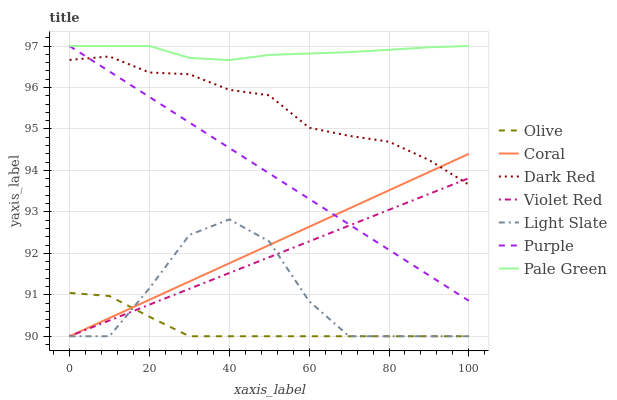Does Olive have the minimum area under the curve?
Answer yes or no. Yes. Does Pale Green have the maximum area under the curve?
Answer yes or no. Yes. Does Purple have the minimum area under the curve?
Answer yes or no. No. Does Purple have the maximum area under the curve?
Answer yes or no. No. Is Violet Red the smoothest?
Answer yes or no. Yes. Is Light Slate the roughest?
Answer yes or no. Yes. Is Purple the smoothest?
Answer yes or no. No. Is Purple the roughest?
Answer yes or no. No. Does Violet Red have the lowest value?
Answer yes or no. Yes. Does Purple have the lowest value?
Answer yes or no. No. Does Pale Green have the highest value?
Answer yes or no. Yes. Does Dark Red have the highest value?
Answer yes or no. No. Is Olive less than Pale Green?
Answer yes or no. Yes. Is Dark Red greater than Light Slate?
Answer yes or no. Yes. Does Olive intersect Violet Red?
Answer yes or no. Yes. Is Olive less than Violet Red?
Answer yes or no. No. Is Olive greater than Violet Red?
Answer yes or no. No. Does Olive intersect Pale Green?
Answer yes or no. No. 